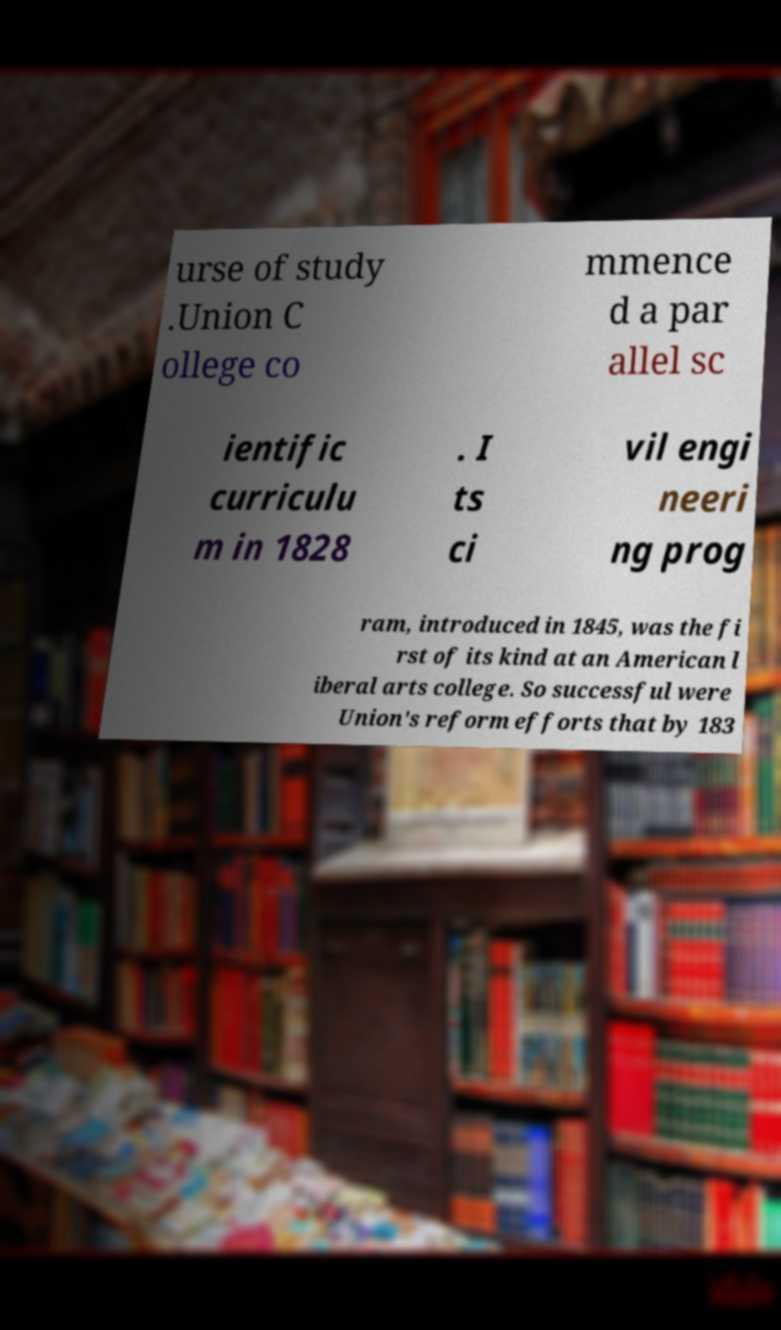Could you assist in decoding the text presented in this image and type it out clearly? urse of study .Union C ollege co mmence d a par allel sc ientific curriculu m in 1828 . I ts ci vil engi neeri ng prog ram, introduced in 1845, was the fi rst of its kind at an American l iberal arts college. So successful were Union's reform efforts that by 183 